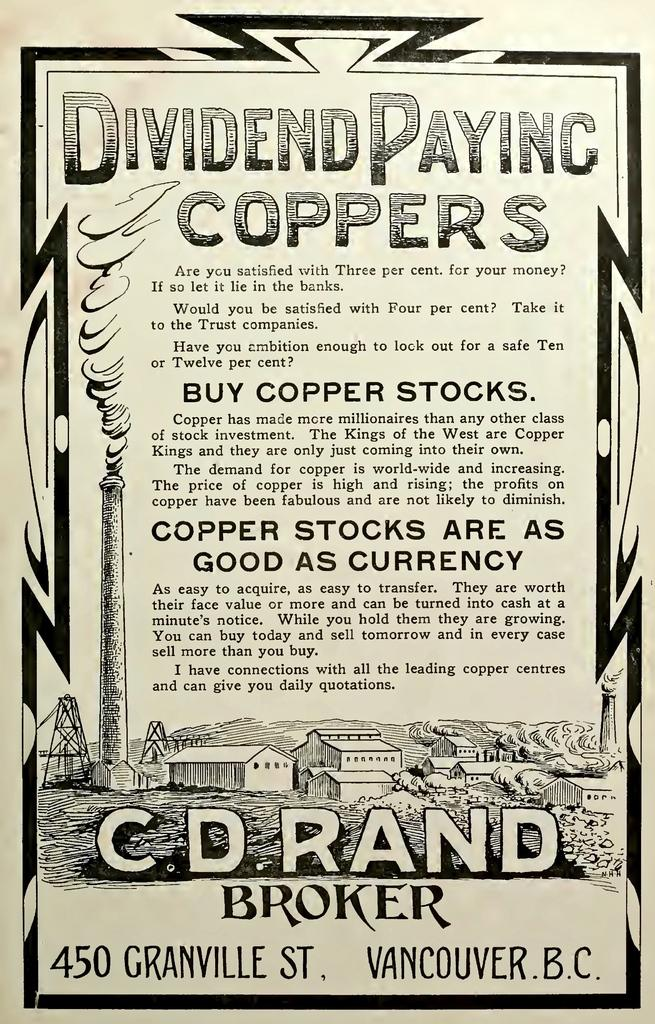<image>
Create a compact narrative representing the image presented. A poster by CD Rand, a Broker from Vancouver, advertising Copper stock sales. 